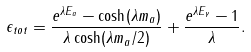Convert formula to latex. <formula><loc_0><loc_0><loc_500><loc_500>\epsilon _ { t o t } = \frac { e ^ { \lambda E _ { a } } - \cosh ( \lambda m _ { a } ) } { \lambda \cosh ( \lambda m _ { a } / 2 ) } + \frac { e ^ { \lambda E _ { \gamma } } - 1 } { \lambda } .</formula> 